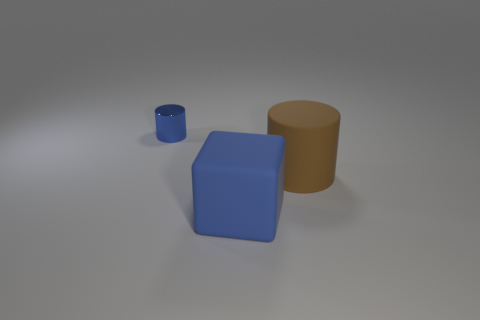There is a large matte thing behind the blue thing to the right of the cylinder that is behind the large brown matte object; what is its shape? The object you're referring to appears to be a blue block, which has a cubical shape. It's situated behind the blue cylinder and to the right of a larger, brown cylinder, which itself seems to have a matte finish. 